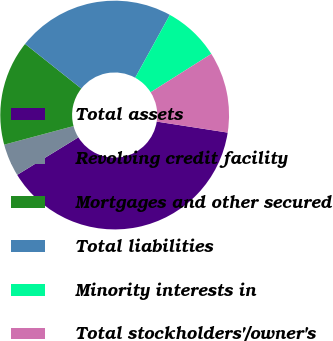Convert chart to OTSL. <chart><loc_0><loc_0><loc_500><loc_500><pie_chart><fcel>Total assets<fcel>Revolving credit facility<fcel>Mortgages and other secured<fcel>Total liabilities<fcel>Minority interests in<fcel>Total stockholders'/owner's<nl><fcel>38.79%<fcel>4.59%<fcel>14.85%<fcel>22.33%<fcel>8.01%<fcel>11.43%<nl></chart> 